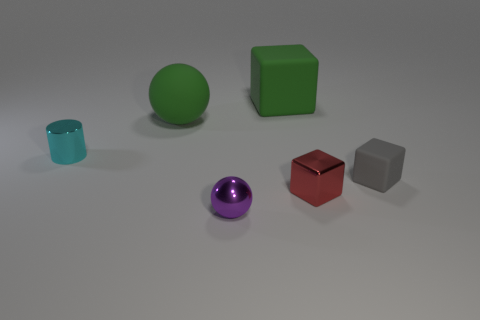What color is the tiny metal cylinder?
Give a very brief answer. Cyan. There is a rubber object left of the big matte block; what is its size?
Your response must be concise. Large. How many large matte balls are behind the small thing behind the rubber cube that is in front of the big rubber ball?
Ensure brevity in your answer.  1. The shiny object that is to the right of the big rubber thing that is behind the green matte ball is what color?
Give a very brief answer. Red. Are there any red cubes that have the same size as the purple metal thing?
Your answer should be very brief. Yes. There is a block in front of the rubber thing right of the block that is behind the small cyan object; what is it made of?
Your answer should be very brief. Metal. What number of large matte things are to the right of the tiny cube behind the small shiny cube?
Make the answer very short. 0. Does the ball in front of the rubber sphere have the same size as the tiny cyan shiny cylinder?
Offer a very short reply. Yes. How many large green matte things are the same shape as the tiny purple metallic thing?
Offer a terse response. 1. What is the shape of the tiny purple thing?
Your answer should be very brief. Sphere. 